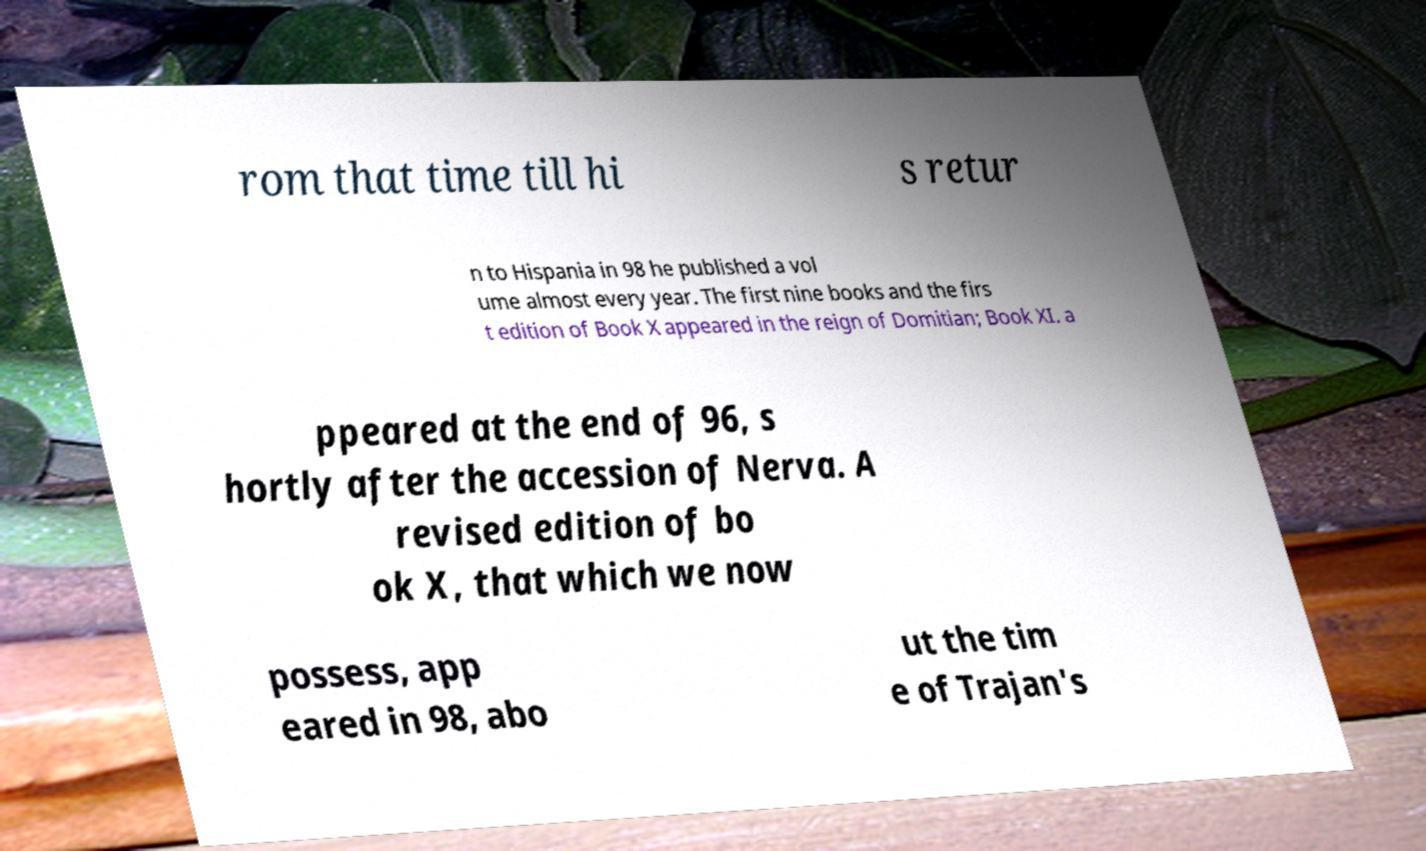I need the written content from this picture converted into text. Can you do that? rom that time till hi s retur n to Hispania in 98 he published a vol ume almost every year. The first nine books and the firs t edition of Book X appeared in the reign of Domitian; Book XI. a ppeared at the end of 96, s hortly after the accession of Nerva. A revised edition of bo ok X, that which we now possess, app eared in 98, abo ut the tim e of Trajan's 